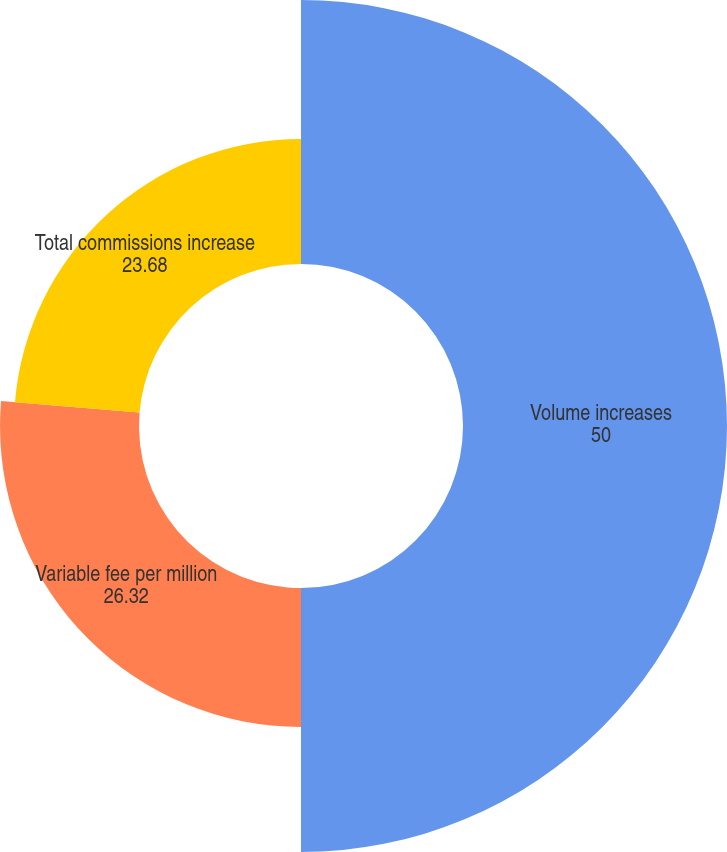<chart> <loc_0><loc_0><loc_500><loc_500><pie_chart><fcel>Volume increases<fcel>Variable fee per million<fcel>Total commissions increase<nl><fcel>50.0%<fcel>26.32%<fcel>23.68%<nl></chart> 